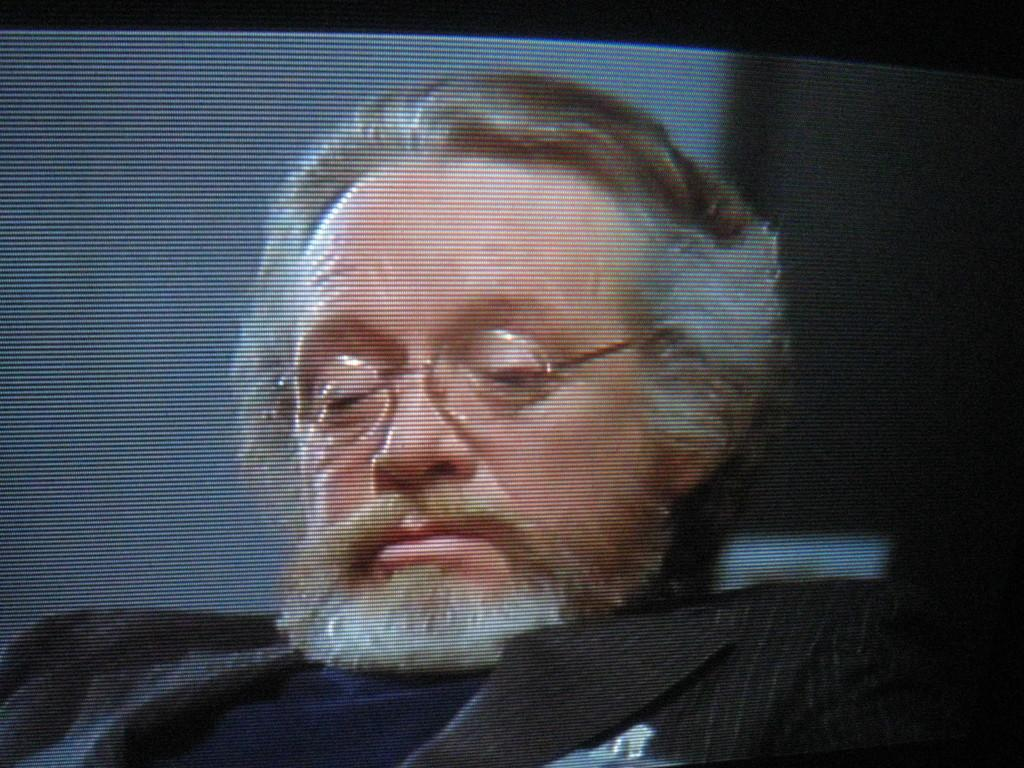What is the main subject in the foreground of the image? There is a man in the foreground of the image. What is the man wearing in the image? The man is wearing a blazer and spectacles. What type of drain is visible in the image? There is no drain present in the image; it features a man wearing a blazer and spectacles. What relation does the man have with the person standing next to him in the image? There is no other person visible in the image, so it is not possible to determine any relation. 